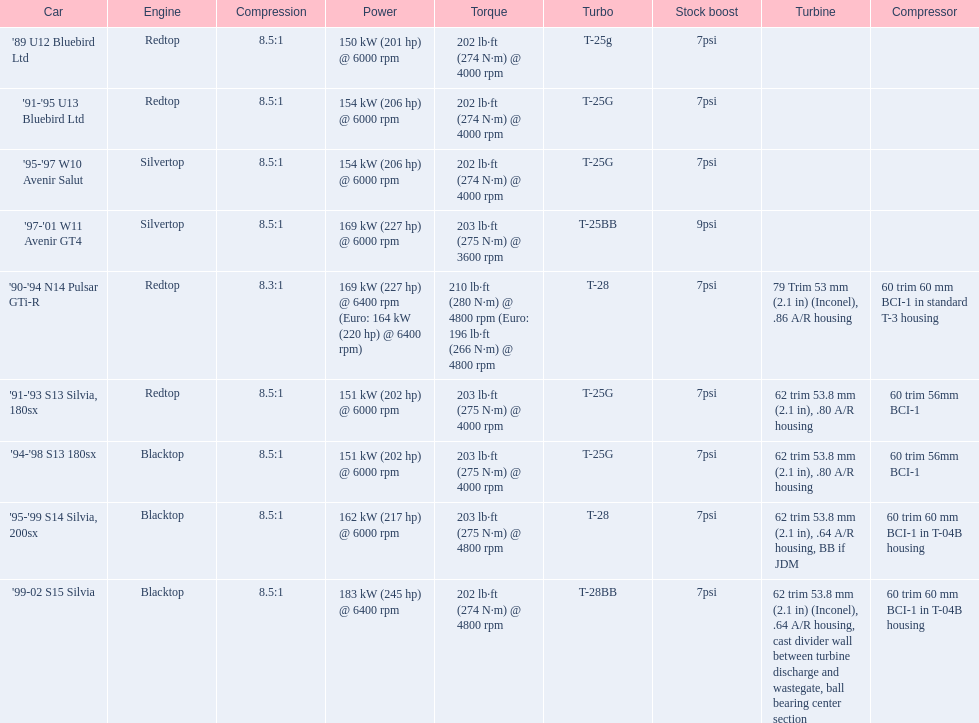What automobiles are available? '89 U12 Bluebird Ltd, 7psi, '91-'95 U13 Bluebird Ltd, 7psi, '95-'97 W10 Avenir Salut, 7psi, '97-'01 W11 Avenir GT4, 9psi, '90-'94 N14 Pulsar GTi-R, 7psi, '91-'93 S13 Silvia, 180sx, 7psi, '94-'98 S13 180sx, 7psi, '95-'99 S14 Silvia, 200sx, 7psi, '99-02 S15 Silvia, 7psi. Which factory boost exceeds 7psi? '97-'01 W11 Avenir GT4, 9psi. Which vehicle is it? '97-'01 W11 Avenir GT4. 